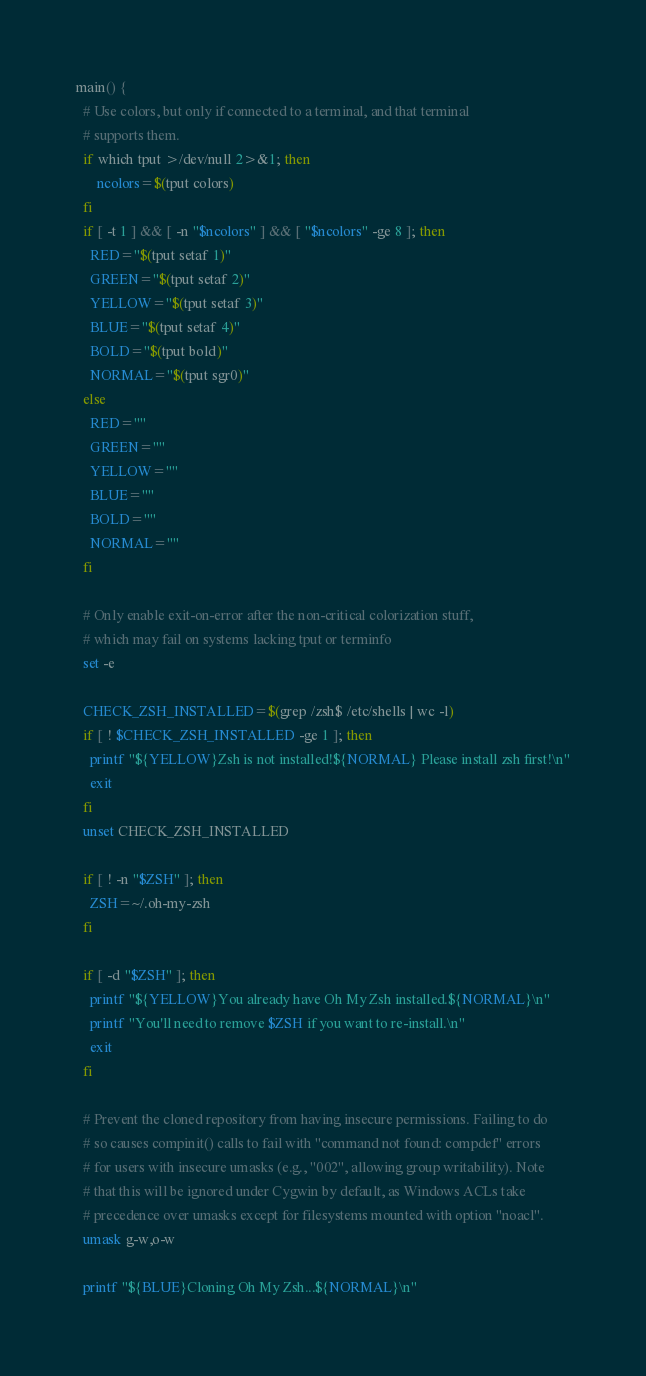Convert code to text. <code><loc_0><loc_0><loc_500><loc_500><_Bash_>main() {
  # Use colors, but only if connected to a terminal, and that terminal
  # supports them.
  if which tput >/dev/null 2>&1; then
      ncolors=$(tput colors)
  fi
  if [ -t 1 ] && [ -n "$ncolors" ] && [ "$ncolors" -ge 8 ]; then
    RED="$(tput setaf 1)"
    GREEN="$(tput setaf 2)"
    YELLOW="$(tput setaf 3)"
    BLUE="$(tput setaf 4)"
    BOLD="$(tput bold)"
    NORMAL="$(tput sgr0)"
  else
    RED=""
    GREEN=""
    YELLOW=""
    BLUE=""
    BOLD=""
    NORMAL=""
  fi

  # Only enable exit-on-error after the non-critical colorization stuff,
  # which may fail on systems lacking tput or terminfo
  set -e

  CHECK_ZSH_INSTALLED=$(grep /zsh$ /etc/shells | wc -l)
  if [ ! $CHECK_ZSH_INSTALLED -ge 1 ]; then
    printf "${YELLOW}Zsh is not installed!${NORMAL} Please install zsh first!\n"
    exit
  fi
  unset CHECK_ZSH_INSTALLED

  if [ ! -n "$ZSH" ]; then
    ZSH=~/.oh-my-zsh
  fi

  if [ -d "$ZSH" ]; then
    printf "${YELLOW}You already have Oh My Zsh installed.${NORMAL}\n"
    printf "You'll need to remove $ZSH if you want to re-install.\n"
    exit
  fi

  # Prevent the cloned repository from having insecure permissions. Failing to do
  # so causes compinit() calls to fail with "command not found: compdef" errors
  # for users with insecure umasks (e.g., "002", allowing group writability). Note
  # that this will be ignored under Cygwin by default, as Windows ACLs take
  # precedence over umasks except for filesystems mounted with option "noacl".
  umask g-w,o-w

  printf "${BLUE}Cloning Oh My Zsh...${NORMAL}\n"</code> 